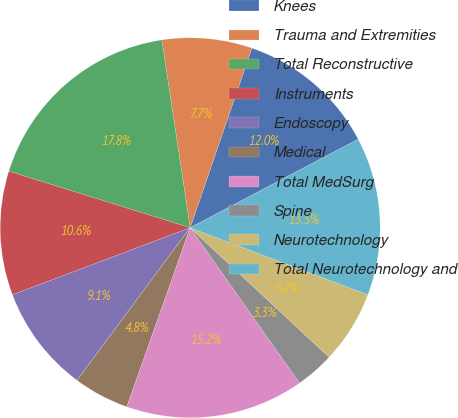Convert chart to OTSL. <chart><loc_0><loc_0><loc_500><loc_500><pie_chart><fcel>Knees<fcel>Trauma and Extremities<fcel>Total Reconstructive<fcel>Instruments<fcel>Endoscopy<fcel>Medical<fcel>Total MedSurg<fcel>Spine<fcel>Neurotechnology<fcel>Total Neurotechnology and<nl><fcel>12.01%<fcel>7.65%<fcel>17.81%<fcel>10.55%<fcel>9.1%<fcel>4.75%<fcel>15.17%<fcel>3.3%<fcel>6.2%<fcel>13.46%<nl></chart> 